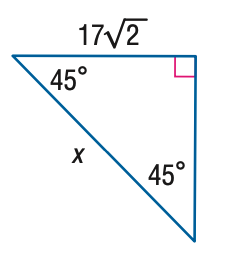Question: Find x.
Choices:
A. 17
B. 17 \sqrt { 2 }
C. 34
D. 17 \sqrt { 6 }
Answer with the letter. Answer: C 